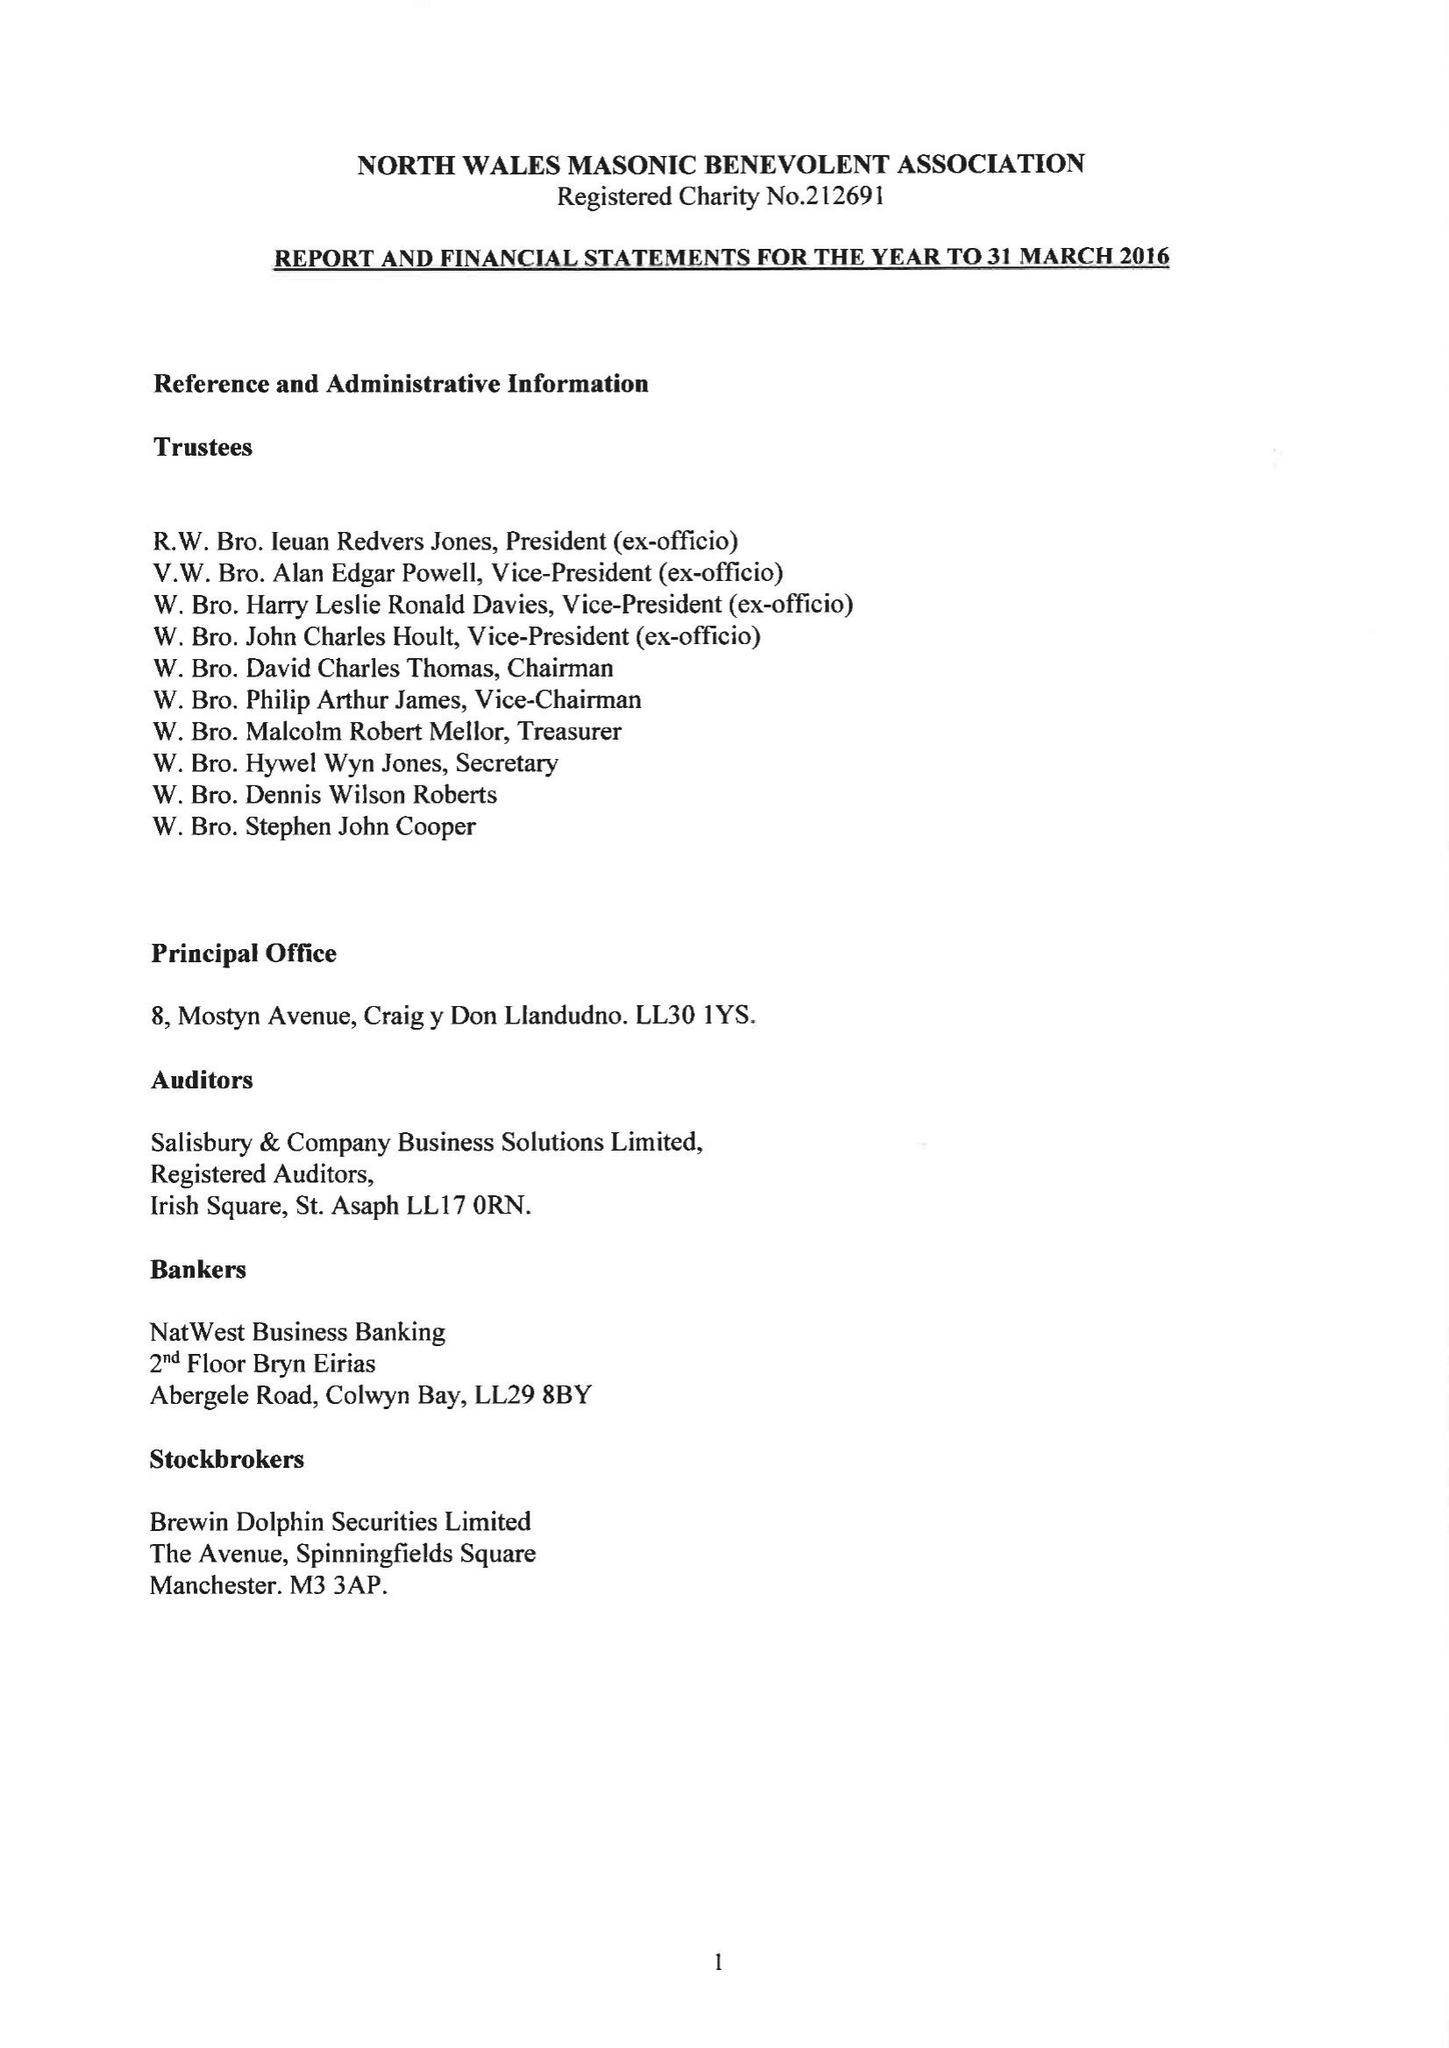What is the value for the address__post_town?
Answer the question using a single word or phrase. LLANDUDNO 